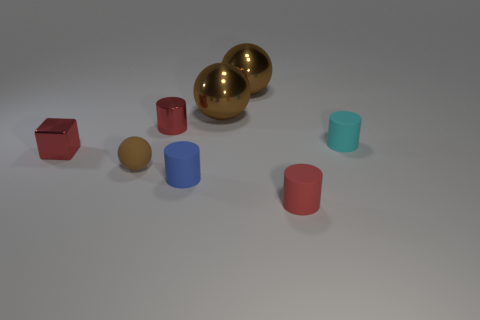The small red cylinder that is in front of the matte cylinder behind the small rubber ball that is on the right side of the metal cube is made of what material?
Make the answer very short. Rubber. What size is the red metal object that is left of the brown ball that is in front of the small cyan matte cylinder?
Ensure brevity in your answer.  Small. There is a tiny shiny thing that is the same shape as the red rubber thing; what is its color?
Offer a very short reply. Red. How many things have the same color as the tiny cube?
Provide a succinct answer. 2. Is the blue cylinder the same size as the brown matte sphere?
Give a very brief answer. Yes. What is the tiny sphere made of?
Keep it short and to the point. Rubber. What is the color of the small sphere that is made of the same material as the cyan cylinder?
Your answer should be compact. Brown. Are the block and the brown thing that is in front of the tiny red metal cylinder made of the same material?
Offer a terse response. No. What number of cylinders have the same material as the cyan object?
Provide a short and direct response. 2. There is a thing that is on the left side of the tiny brown matte sphere; what shape is it?
Give a very brief answer. Cube. 